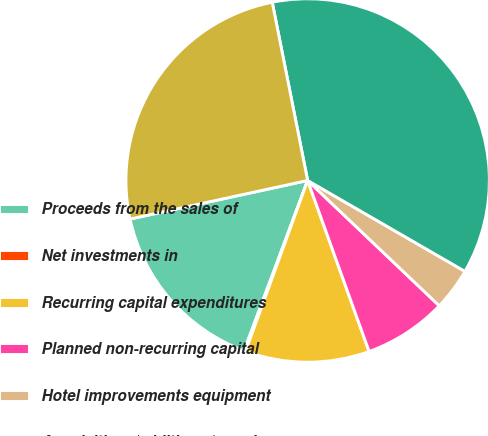Convert chart to OTSL. <chart><loc_0><loc_0><loc_500><loc_500><pie_chart><fcel>Proceeds from the sales of<fcel>Net investments in<fcel>Recurring capital expenditures<fcel>Planned non-recurring capital<fcel>Hotel improvements equipment<fcel>Acquisitions/additions to real<fcel>Net cash used in investing<nl><fcel>15.91%<fcel>0.14%<fcel>11.04%<fcel>7.4%<fcel>3.77%<fcel>36.46%<fcel>25.28%<nl></chart> 